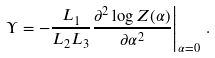<formula> <loc_0><loc_0><loc_500><loc_500>\left . \Upsilon = - \frac { L _ { 1 } } { L _ { 2 } L _ { 3 } } \frac { \partial ^ { 2 } \log Z ( \alpha ) } { \partial \alpha ^ { 2 } } \right | _ { \alpha = 0 } \, .</formula> 